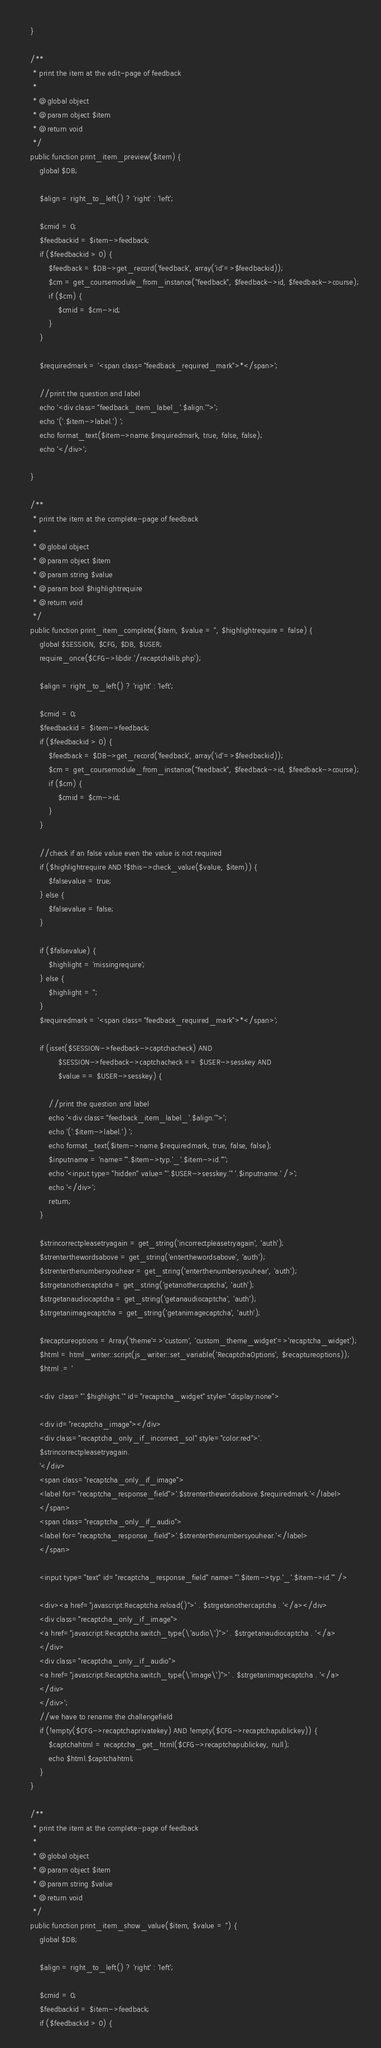<code> <loc_0><loc_0><loc_500><loc_500><_PHP_>    }

    /**
     * print the item at the edit-page of feedback
     *
     * @global object
     * @param object $item
     * @return void
     */
    public function print_item_preview($item) {
        global $DB;

        $align = right_to_left() ? 'right' : 'left';

        $cmid = 0;
        $feedbackid = $item->feedback;
        if ($feedbackid > 0) {
            $feedback = $DB->get_record('feedback', array('id'=>$feedbackid));
            $cm = get_coursemodule_from_instance("feedback", $feedback->id, $feedback->course);
            if ($cm) {
                $cmid = $cm->id;
            }
        }

        $requiredmark = '<span class="feedback_required_mark">*</span>';

        //print the question and label
        echo '<div class="feedback_item_label_'.$align.'">';
        echo '('.$item->label.') ';
        echo format_text($item->name.$requiredmark, true, false, false);
        echo '</div>';

    }

    /**
     * print the item at the complete-page of feedback
     *
     * @global object
     * @param object $item
     * @param string $value
     * @param bool $highlightrequire
     * @return void
     */
    public function print_item_complete($item, $value = '', $highlightrequire = false) {
        global $SESSION, $CFG, $DB, $USER;
        require_once($CFG->libdir.'/recaptchalib.php');

        $align = right_to_left() ? 'right' : 'left';

        $cmid = 0;
        $feedbackid = $item->feedback;
        if ($feedbackid > 0) {
            $feedback = $DB->get_record('feedback', array('id'=>$feedbackid));
            $cm = get_coursemodule_from_instance("feedback", $feedback->id, $feedback->course);
            if ($cm) {
                $cmid = $cm->id;
            }
        }

        //check if an false value even the value is not required
        if ($highlightrequire AND !$this->check_value($value, $item)) {
            $falsevalue = true;
        } else {
            $falsevalue = false;
        }

        if ($falsevalue) {
            $highlight = 'missingrequire';
        } else {
            $highlight = '';
        }
        $requiredmark = '<span class="feedback_required_mark">*</span>';

        if (isset($SESSION->feedback->captchacheck) AND
                $SESSION->feedback->captchacheck == $USER->sesskey AND
                $value == $USER->sesskey) {

            //print the question and label
            echo '<div class="feedback_item_label_'.$align.'">';
            echo '('.$item->label.') ';
            echo format_text($item->name.$requiredmark, true, false, false);
            $inputname = 'name="'.$item->typ.'_'.$item->id.'"';
            echo '<input type="hidden" value="'.$USER->sesskey.'" '.$inputname.' />';
            echo '</div>';
            return;
        }

        $strincorrectpleasetryagain = get_string('incorrectpleasetryagain', 'auth');
        $strenterthewordsabove = get_string('enterthewordsabove', 'auth');
        $strenterthenumbersyouhear = get_string('enterthenumbersyouhear', 'auth');
        $strgetanothercaptcha = get_string('getanothercaptcha', 'auth');
        $strgetanaudiocaptcha = get_string('getanaudiocaptcha', 'auth');
        $strgetanimagecaptcha = get_string('getanimagecaptcha', 'auth');

        $recaptureoptions = Array('theme'=>'custom', 'custom_theme_widget'=>'recaptcha_widget');
        $html = html_writer::script(js_writer::set_variable('RecaptchaOptions', $recaptureoptions));
        $html .= '

        <div  class="'.$highlight.'" id="recaptcha_widget" style="display:none">

        <div id="recaptcha_image"></div>
        <div class="recaptcha_only_if_incorrect_sol" style="color:red">'.
        $strincorrectpleasetryagain.
        '</div>
        <span class="recaptcha_only_if_image">
        <label for="recaptcha_response_field">'.$strenterthewordsabove.$requiredmark.'</label>
        </span>
        <span class="recaptcha_only_if_audio">
        <label for="recaptcha_response_field">'.$strenterthenumbersyouhear.'</label>
        </span>

        <input type="text" id="recaptcha_response_field" name="'.$item->typ.'_'.$item->id.'" />

        <div><a href="javascript:Recaptcha.reload()">' . $strgetanothercaptcha . '</a></div>
        <div class="recaptcha_only_if_image">
        <a href="javascript:Recaptcha.switch_type(\'audio\')">' . $strgetanaudiocaptcha . '</a>
        </div>
        <div class="recaptcha_only_if_audio">
        <a href="javascript:Recaptcha.switch_type(\'image\')">' . $strgetanimagecaptcha . '</a>
        </div>
        </div>';
        //we have to rename the challengefield
        if (!empty($CFG->recaptchaprivatekey) AND !empty($CFG->recaptchapublickey)) {
            $captchahtml = recaptcha_get_html($CFG->recaptchapublickey, null);
            echo $html.$captchahtml;
        }
    }

    /**
     * print the item at the complete-page of feedback
     *
     * @global object
     * @param object $item
     * @param string $value
     * @return void
     */
    public function print_item_show_value($item, $value = '') {
        global $DB;

        $align = right_to_left() ? 'right' : 'left';

        $cmid = 0;
        $feedbackid = $item->feedback;
        if ($feedbackid > 0) {</code> 